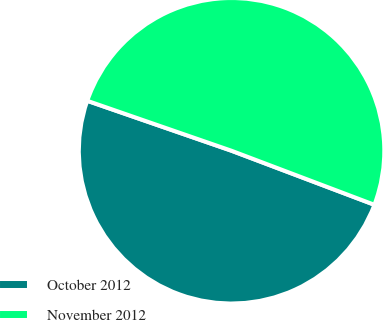Convert chart. <chart><loc_0><loc_0><loc_500><loc_500><pie_chart><fcel>October 2012<fcel>November 2012<nl><fcel>49.55%<fcel>50.45%<nl></chart> 